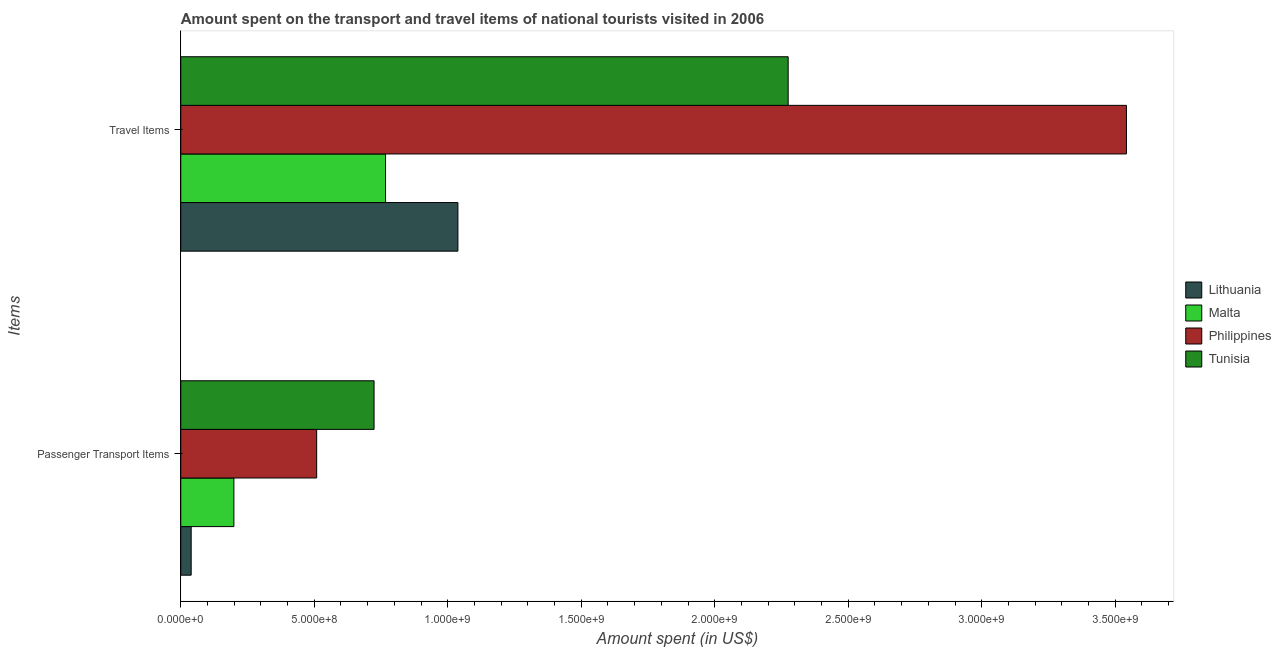How many different coloured bars are there?
Ensure brevity in your answer.  4. How many groups of bars are there?
Your answer should be very brief. 2. Are the number of bars per tick equal to the number of legend labels?
Keep it short and to the point. Yes. Are the number of bars on each tick of the Y-axis equal?
Your answer should be compact. Yes. How many bars are there on the 1st tick from the bottom?
Keep it short and to the point. 4. What is the label of the 1st group of bars from the top?
Offer a terse response. Travel Items. What is the amount spent on passenger transport items in Tunisia?
Make the answer very short. 7.24e+08. Across all countries, what is the maximum amount spent in travel items?
Provide a succinct answer. 3.54e+09. Across all countries, what is the minimum amount spent in travel items?
Your answer should be compact. 7.67e+08. In which country was the amount spent on passenger transport items maximum?
Offer a terse response. Tunisia. In which country was the amount spent in travel items minimum?
Provide a succinct answer. Malta. What is the total amount spent on passenger transport items in the graph?
Give a very brief answer. 1.47e+09. What is the difference between the amount spent on passenger transport items in Tunisia and that in Malta?
Your response must be concise. 5.25e+08. What is the difference between the amount spent on passenger transport items in Malta and the amount spent in travel items in Tunisia?
Your response must be concise. -2.08e+09. What is the average amount spent on passenger transport items per country?
Give a very brief answer. 3.68e+08. What is the difference between the amount spent on passenger transport items and amount spent in travel items in Tunisia?
Provide a succinct answer. -1.55e+09. In how many countries, is the amount spent on passenger transport items greater than 1200000000 US$?
Provide a short and direct response. 0. What is the ratio of the amount spent in travel items in Lithuania to that in Tunisia?
Keep it short and to the point. 0.46. Does the graph contain any zero values?
Your answer should be very brief. No. What is the title of the graph?
Offer a terse response. Amount spent on the transport and travel items of national tourists visited in 2006. What is the label or title of the X-axis?
Your answer should be compact. Amount spent (in US$). What is the label or title of the Y-axis?
Offer a terse response. Items. What is the Amount spent (in US$) in Lithuania in Passenger Transport Items?
Keep it short and to the point. 3.90e+07. What is the Amount spent (in US$) of Malta in Passenger Transport Items?
Ensure brevity in your answer.  1.99e+08. What is the Amount spent (in US$) in Philippines in Passenger Transport Items?
Your answer should be compact. 5.09e+08. What is the Amount spent (in US$) in Tunisia in Passenger Transport Items?
Give a very brief answer. 7.24e+08. What is the Amount spent (in US$) of Lithuania in Travel Items?
Make the answer very short. 1.04e+09. What is the Amount spent (in US$) in Malta in Travel Items?
Your answer should be compact. 7.67e+08. What is the Amount spent (in US$) in Philippines in Travel Items?
Your answer should be compact. 3.54e+09. What is the Amount spent (in US$) of Tunisia in Travel Items?
Your answer should be very brief. 2.28e+09. Across all Items, what is the maximum Amount spent (in US$) of Lithuania?
Your answer should be very brief. 1.04e+09. Across all Items, what is the maximum Amount spent (in US$) of Malta?
Keep it short and to the point. 7.67e+08. Across all Items, what is the maximum Amount spent (in US$) in Philippines?
Ensure brevity in your answer.  3.54e+09. Across all Items, what is the maximum Amount spent (in US$) of Tunisia?
Ensure brevity in your answer.  2.28e+09. Across all Items, what is the minimum Amount spent (in US$) of Lithuania?
Offer a terse response. 3.90e+07. Across all Items, what is the minimum Amount spent (in US$) of Malta?
Keep it short and to the point. 1.99e+08. Across all Items, what is the minimum Amount spent (in US$) in Philippines?
Make the answer very short. 5.09e+08. Across all Items, what is the minimum Amount spent (in US$) in Tunisia?
Your response must be concise. 7.24e+08. What is the total Amount spent (in US$) in Lithuania in the graph?
Provide a short and direct response. 1.08e+09. What is the total Amount spent (in US$) in Malta in the graph?
Give a very brief answer. 9.66e+08. What is the total Amount spent (in US$) of Philippines in the graph?
Your response must be concise. 4.05e+09. What is the total Amount spent (in US$) in Tunisia in the graph?
Your answer should be very brief. 3.00e+09. What is the difference between the Amount spent (in US$) of Lithuania in Passenger Transport Items and that in Travel Items?
Keep it short and to the point. -9.99e+08. What is the difference between the Amount spent (in US$) in Malta in Passenger Transport Items and that in Travel Items?
Your response must be concise. -5.68e+08. What is the difference between the Amount spent (in US$) in Philippines in Passenger Transport Items and that in Travel Items?
Offer a terse response. -3.03e+09. What is the difference between the Amount spent (in US$) in Tunisia in Passenger Transport Items and that in Travel Items?
Provide a succinct answer. -1.55e+09. What is the difference between the Amount spent (in US$) of Lithuania in Passenger Transport Items and the Amount spent (in US$) of Malta in Travel Items?
Offer a terse response. -7.28e+08. What is the difference between the Amount spent (in US$) in Lithuania in Passenger Transport Items and the Amount spent (in US$) in Philippines in Travel Items?
Make the answer very short. -3.50e+09. What is the difference between the Amount spent (in US$) in Lithuania in Passenger Transport Items and the Amount spent (in US$) in Tunisia in Travel Items?
Your answer should be very brief. -2.24e+09. What is the difference between the Amount spent (in US$) of Malta in Passenger Transport Items and the Amount spent (in US$) of Philippines in Travel Items?
Offer a very short reply. -3.34e+09. What is the difference between the Amount spent (in US$) of Malta in Passenger Transport Items and the Amount spent (in US$) of Tunisia in Travel Items?
Keep it short and to the point. -2.08e+09. What is the difference between the Amount spent (in US$) in Philippines in Passenger Transport Items and the Amount spent (in US$) in Tunisia in Travel Items?
Give a very brief answer. -1.77e+09. What is the average Amount spent (in US$) in Lithuania per Items?
Keep it short and to the point. 5.38e+08. What is the average Amount spent (in US$) of Malta per Items?
Your response must be concise. 4.83e+08. What is the average Amount spent (in US$) of Philippines per Items?
Ensure brevity in your answer.  2.03e+09. What is the average Amount spent (in US$) of Tunisia per Items?
Offer a terse response. 1.50e+09. What is the difference between the Amount spent (in US$) of Lithuania and Amount spent (in US$) of Malta in Passenger Transport Items?
Your answer should be compact. -1.60e+08. What is the difference between the Amount spent (in US$) of Lithuania and Amount spent (in US$) of Philippines in Passenger Transport Items?
Your response must be concise. -4.70e+08. What is the difference between the Amount spent (in US$) of Lithuania and Amount spent (in US$) of Tunisia in Passenger Transport Items?
Your response must be concise. -6.85e+08. What is the difference between the Amount spent (in US$) in Malta and Amount spent (in US$) in Philippines in Passenger Transport Items?
Your answer should be compact. -3.10e+08. What is the difference between the Amount spent (in US$) of Malta and Amount spent (in US$) of Tunisia in Passenger Transport Items?
Offer a terse response. -5.25e+08. What is the difference between the Amount spent (in US$) in Philippines and Amount spent (in US$) in Tunisia in Passenger Transport Items?
Make the answer very short. -2.15e+08. What is the difference between the Amount spent (in US$) of Lithuania and Amount spent (in US$) of Malta in Travel Items?
Your response must be concise. 2.71e+08. What is the difference between the Amount spent (in US$) in Lithuania and Amount spent (in US$) in Philippines in Travel Items?
Your response must be concise. -2.50e+09. What is the difference between the Amount spent (in US$) of Lithuania and Amount spent (in US$) of Tunisia in Travel Items?
Offer a very short reply. -1.24e+09. What is the difference between the Amount spent (in US$) in Malta and Amount spent (in US$) in Philippines in Travel Items?
Give a very brief answer. -2.78e+09. What is the difference between the Amount spent (in US$) of Malta and Amount spent (in US$) of Tunisia in Travel Items?
Give a very brief answer. -1.51e+09. What is the difference between the Amount spent (in US$) of Philippines and Amount spent (in US$) of Tunisia in Travel Items?
Ensure brevity in your answer.  1.27e+09. What is the ratio of the Amount spent (in US$) of Lithuania in Passenger Transport Items to that in Travel Items?
Offer a very short reply. 0.04. What is the ratio of the Amount spent (in US$) in Malta in Passenger Transport Items to that in Travel Items?
Offer a terse response. 0.26. What is the ratio of the Amount spent (in US$) of Philippines in Passenger Transport Items to that in Travel Items?
Offer a terse response. 0.14. What is the ratio of the Amount spent (in US$) of Tunisia in Passenger Transport Items to that in Travel Items?
Your answer should be compact. 0.32. What is the difference between the highest and the second highest Amount spent (in US$) in Lithuania?
Your answer should be compact. 9.99e+08. What is the difference between the highest and the second highest Amount spent (in US$) of Malta?
Provide a succinct answer. 5.68e+08. What is the difference between the highest and the second highest Amount spent (in US$) of Philippines?
Provide a succinct answer. 3.03e+09. What is the difference between the highest and the second highest Amount spent (in US$) of Tunisia?
Offer a very short reply. 1.55e+09. What is the difference between the highest and the lowest Amount spent (in US$) in Lithuania?
Your answer should be compact. 9.99e+08. What is the difference between the highest and the lowest Amount spent (in US$) in Malta?
Your answer should be compact. 5.68e+08. What is the difference between the highest and the lowest Amount spent (in US$) in Philippines?
Offer a terse response. 3.03e+09. What is the difference between the highest and the lowest Amount spent (in US$) in Tunisia?
Keep it short and to the point. 1.55e+09. 